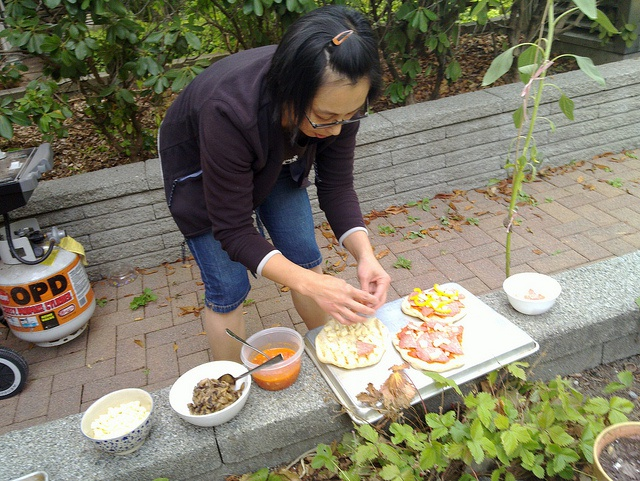Describe the objects in this image and their specific colors. I can see people in gray, black, navy, and tan tones, bowl in gray, white, darkgray, and tan tones, bowl in gray, ivory, darkgray, and khaki tones, pizza in gray, beige, khaki, and tan tones, and pizza in gray, ivory, tan, and lightpink tones in this image. 